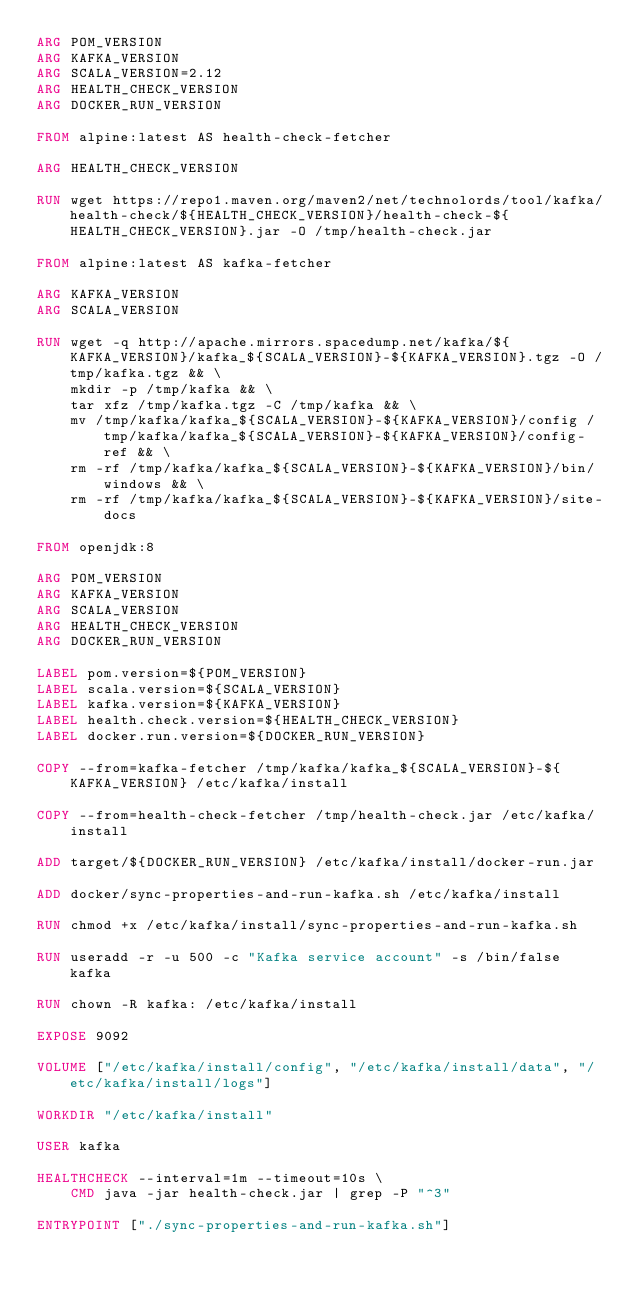Convert code to text. <code><loc_0><loc_0><loc_500><loc_500><_Dockerfile_>ARG POM_VERSION
ARG KAFKA_VERSION
ARG SCALA_VERSION=2.12
ARG HEALTH_CHECK_VERSION
ARG DOCKER_RUN_VERSION

FROM alpine:latest AS health-check-fetcher

ARG HEALTH_CHECK_VERSION

RUN wget https://repo1.maven.org/maven2/net/technolords/tool/kafka/health-check/${HEALTH_CHECK_VERSION}/health-check-${HEALTH_CHECK_VERSION}.jar -O /tmp/health-check.jar

FROM alpine:latest AS kafka-fetcher

ARG KAFKA_VERSION
ARG SCALA_VERSION

RUN wget -q http://apache.mirrors.spacedump.net/kafka/${KAFKA_VERSION}/kafka_${SCALA_VERSION}-${KAFKA_VERSION}.tgz -O /tmp/kafka.tgz && \
    mkdir -p /tmp/kafka && \
    tar xfz /tmp/kafka.tgz -C /tmp/kafka && \
    mv /tmp/kafka/kafka_${SCALA_VERSION}-${KAFKA_VERSION}/config /tmp/kafka/kafka_${SCALA_VERSION}-${KAFKA_VERSION}/config-ref && \
    rm -rf /tmp/kafka/kafka_${SCALA_VERSION}-${KAFKA_VERSION}/bin/windows && \
    rm -rf /tmp/kafka/kafka_${SCALA_VERSION}-${KAFKA_VERSION}/site-docs

FROM openjdk:8

ARG POM_VERSION
ARG KAFKA_VERSION
ARG SCALA_VERSION
ARG HEALTH_CHECK_VERSION
ARG DOCKER_RUN_VERSION

LABEL pom.version=${POM_VERSION}
LABEL scala.version=${SCALA_VERSION}
LABEL kafka.version=${KAFKA_VERSION}
LABEL health.check.version=${HEALTH_CHECK_VERSION}
LABEL docker.run.version=${DOCKER_RUN_VERSION}

COPY --from=kafka-fetcher /tmp/kafka/kafka_${SCALA_VERSION}-${KAFKA_VERSION} /etc/kafka/install

COPY --from=health-check-fetcher /tmp/health-check.jar /etc/kafka/install

ADD target/${DOCKER_RUN_VERSION} /etc/kafka/install/docker-run.jar

ADD docker/sync-properties-and-run-kafka.sh /etc/kafka/install

RUN chmod +x /etc/kafka/install/sync-properties-and-run-kafka.sh

RUN useradd -r -u 500 -c "Kafka service account" -s /bin/false kafka

RUN chown -R kafka: /etc/kafka/install

EXPOSE 9092

VOLUME ["/etc/kafka/install/config", "/etc/kafka/install/data", "/etc/kafka/install/logs"]

WORKDIR "/etc/kafka/install"

USER kafka

HEALTHCHECK --interval=1m --timeout=10s \
    CMD java -jar health-check.jar | grep -P "^3"

ENTRYPOINT ["./sync-properties-and-run-kafka.sh"]
</code> 